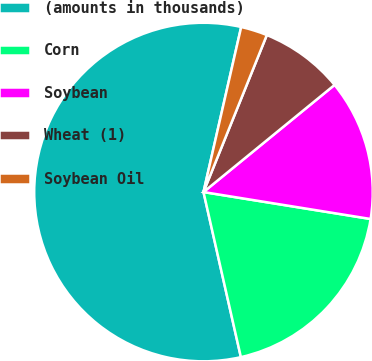<chart> <loc_0><loc_0><loc_500><loc_500><pie_chart><fcel>(amounts in thousands)<fcel>Corn<fcel>Soybean<fcel>Wheat (1)<fcel>Soybean Oil<nl><fcel>57.12%<fcel>18.91%<fcel>13.45%<fcel>7.99%<fcel>2.53%<nl></chart> 